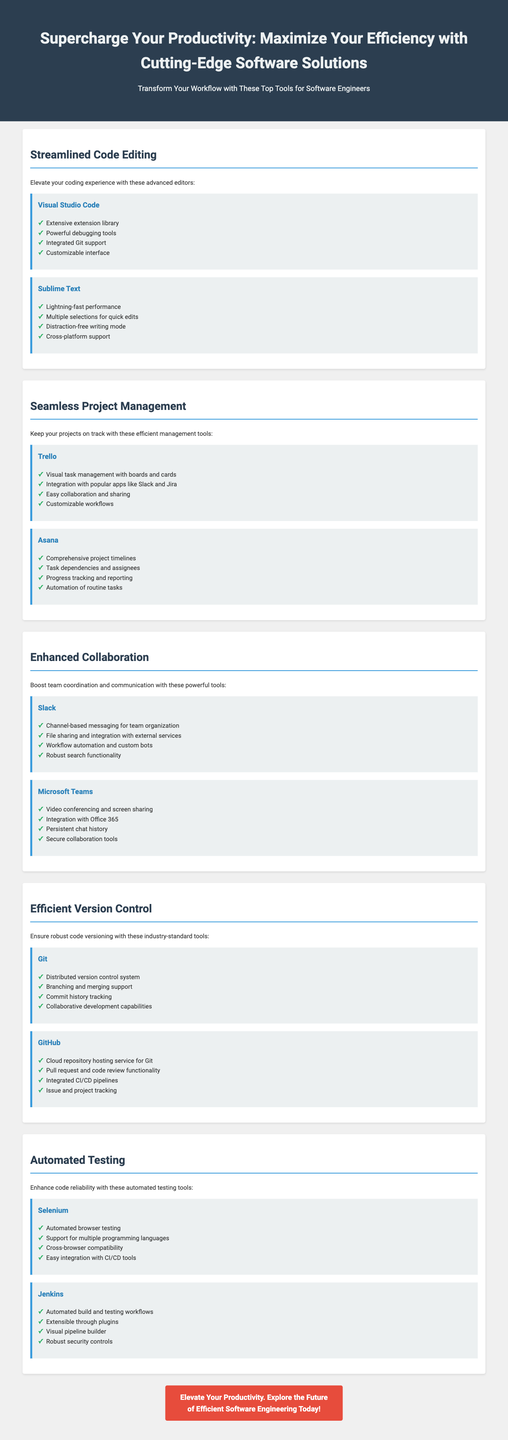what is the title of the document? The title is clearly stated in the header section of the document, which describes the purpose of the advertisement.
Answer: Supercharge Your Productivity: Maximize Your Efficiency with Cutting-Edge Software Solutions how many tools are listed under Streamlined Code Editing? The document specifies two tools in the Streamlined Code Editing section, each accompanied by features.
Answer: 2 which tool offers automation of routine tasks? The document lists this feature under the tool Asana, which is presented in the Seamless Project Management section.
Answer: Asana what type of testing does Selenium focus on? The text in the Automated Testing section directly states the primary function of Selenium, which pertains to its automated capabilities.
Answer: Automated browser testing which section talks about team messaging? The Enhanced Collaboration section of the document focuses specifically on tools that facilitate team communication, including messaging.
Answer: Enhanced Collaboration how many main sections are there in the document? The document is organized into five distinct sections, each focusing on a specific aspect of productivity tools.
Answer: 5 what feature does GitHub provide for code review? The document describes this functionality as part of the GitHub tool in the Efficient Version Control section.
Answer: Pull request and code review functionality which tool is highlighted for visual task management? This feature is mentioned under the Trello tool, which is emphasized in the Seamless Project Management section.
Answer: Trello 